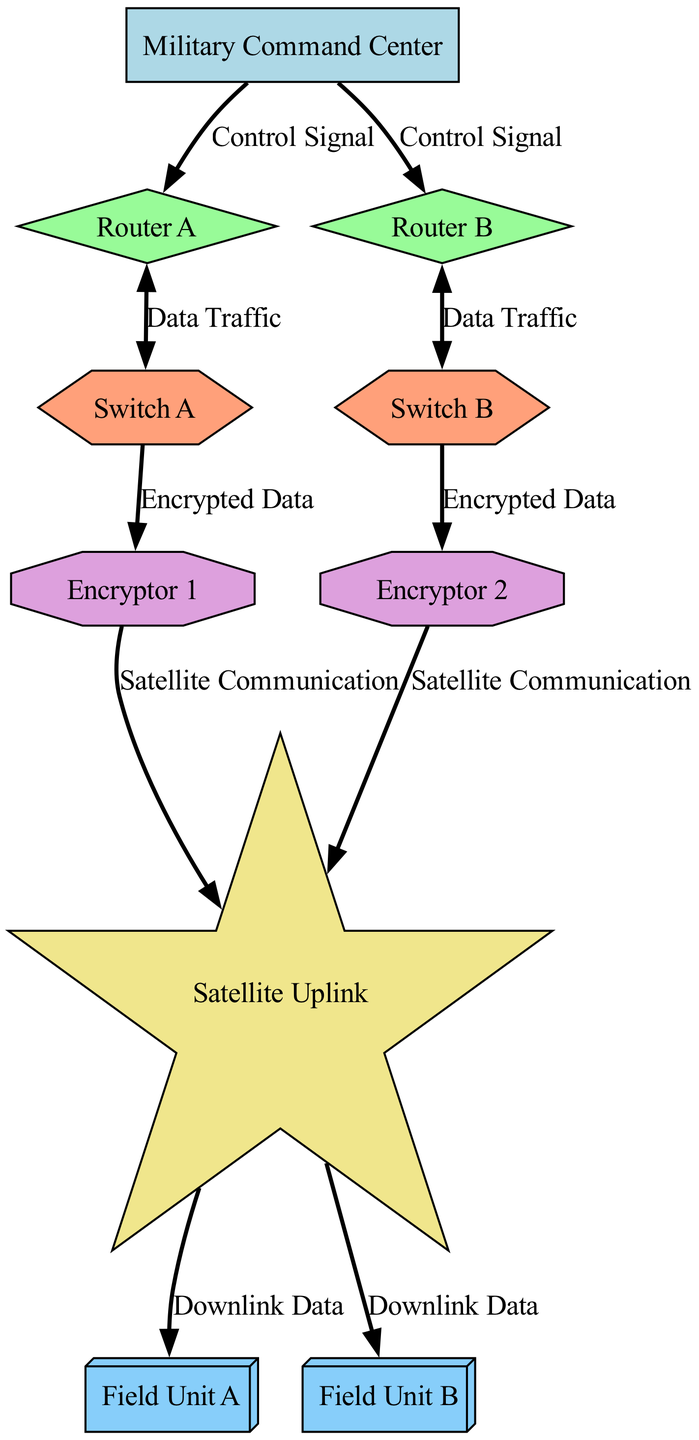What is the main hub in the network? The main hub in the network is labeled "Military Command Center," which acts as the central point for control signals to other components.
Answer: Military Command Center How many routers are present in the system? There are two routers present in the system, labeled "Router A" and "Router B."
Answer: 2 What type of signal connects the Military Command Center to Router A? The connection from the Military Command Center to Router A uses a "Control Signal," which is unidirectional.
Answer: Control Signal Which nodes are responsible for encrypting data? The nodes responsible for encrypting data are labeled "Encryptor 1" and "Encryptor 2." Each encryptor processes data from the switches before it is sent to the satellite uplink.
Answer: Encryptor 1, Encryptor 2 What is the flow of data from Field Unit A to the Military Command Center? The flow of data from Field Unit A begins when it receives downlink data from the satellite, and then it follows the path back to the Military Command Center through the satellite, encryptors, switches, and routers. This path emphasizes the use of encrypted data in military communications.
Answer: Downlink Data -> Satellite Uplink -> Encryptor 1 -> Switch A -> Router A -> Military Command Center How many total edges are there in the diagram? By counting all the connections listed in the edges section, there are a total of eight connections representing the flow of data and control signals between the various components.
Answer: 8 What type of device is connected to Switch A? Switch A is connected to "Encryptor 1," which receives the encrypted data from Switch A before sending it to the satellite.
Answer: Encryptor 1 Which nodes send unidirectional signals? Unidirectional signals are sent from "Military Command Center" to both routers, from "Switch A" to "Encryptor 1," from "Encryptor 1" to "Satellite Uplink," and similarly from "Encryptor 2" to "Satellite Uplink."
Answer: Military Command Center, Switch A, Encryptor 1, Encryptor 2 How does data travel from Router B to Field Unit B? Data travels from Router B to Switch B, then it goes to Encryptor 2, from there it goes to Satellite Uplink before finally reaching Field Unit B through Downlink Data. This path highlights the encryption process before the data is transmitted.
Answer: Router B -> Switch B -> Encryptor 2 -> Satellite Uplink -> Field Unit B 